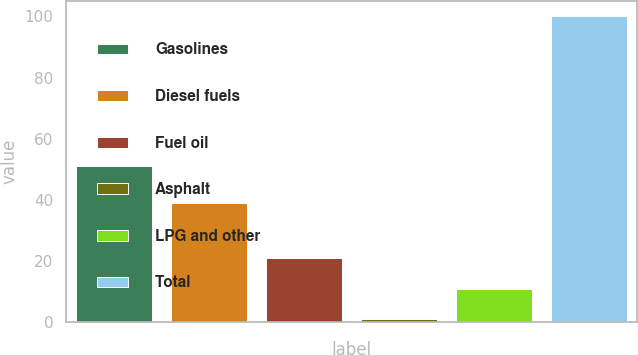Convert chart to OTSL. <chart><loc_0><loc_0><loc_500><loc_500><bar_chart><fcel>Gasolines<fcel>Diesel fuels<fcel>Fuel oil<fcel>Asphalt<fcel>LPG and other<fcel>Total<nl><fcel>51<fcel>39<fcel>20.8<fcel>1<fcel>10.9<fcel>100<nl></chart> 